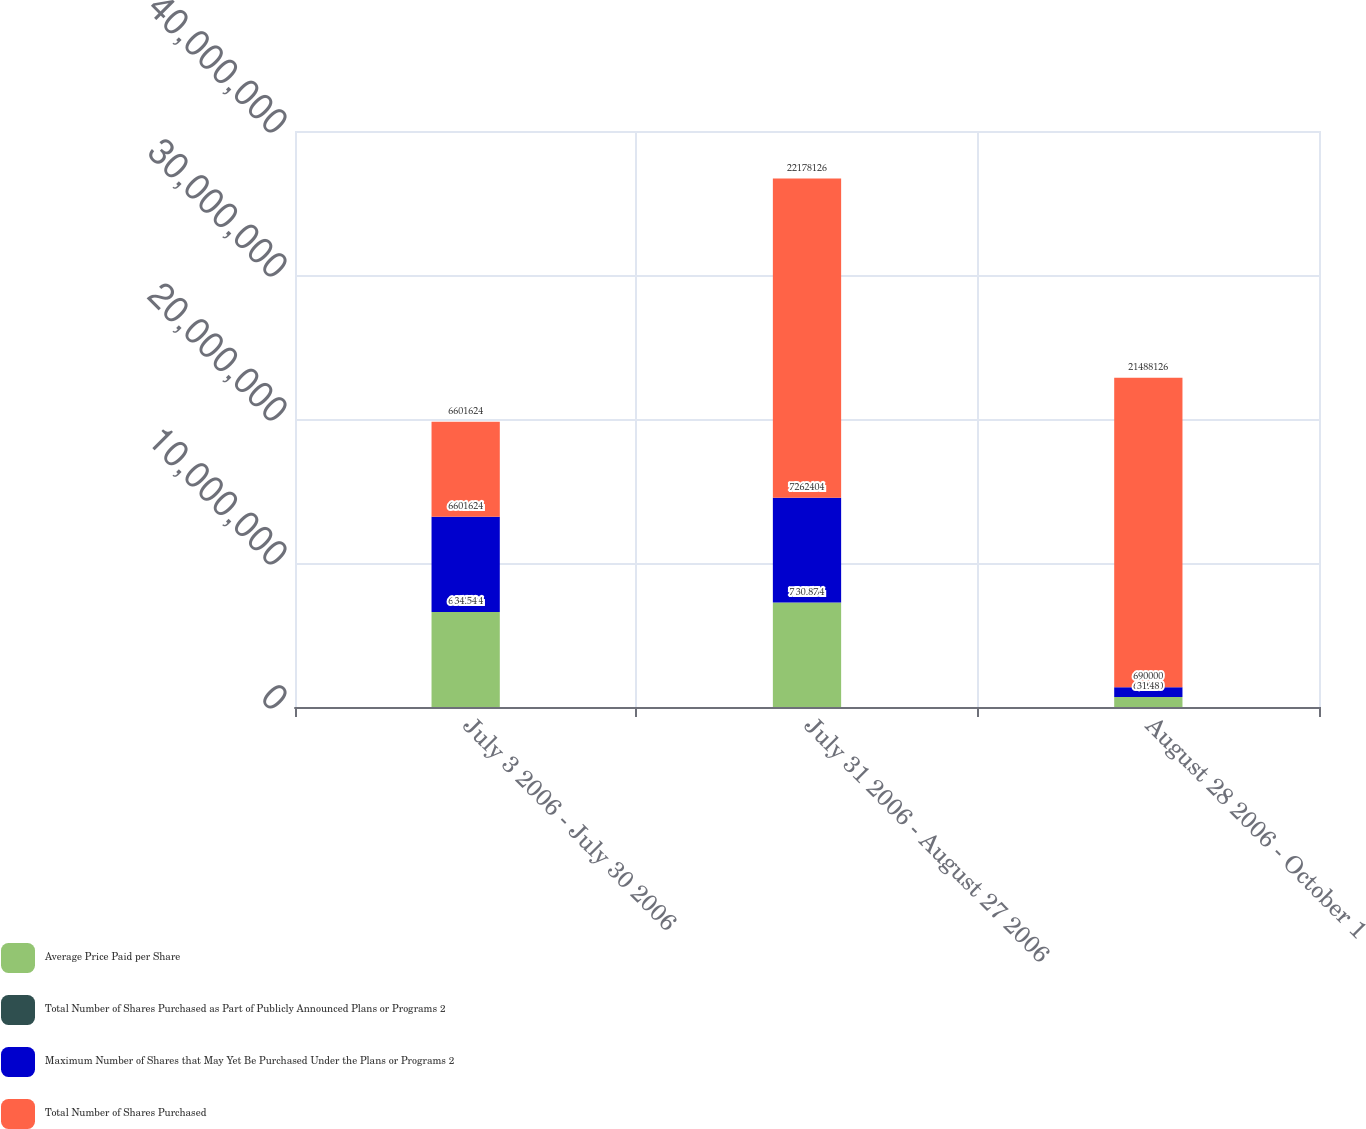Convert chart to OTSL. <chart><loc_0><loc_0><loc_500><loc_500><stacked_bar_chart><ecel><fcel>July 3 2006 - July 30 2006<fcel>July 31 2006 - August 27 2006<fcel>August 28 2006 - October 1<nl><fcel>Average Price Paid per Share<fcel>6.60162e+06<fcel>7.2624e+06<fcel>690000<nl><fcel>Total Number of Shares Purchased as Part of Publicly Announced Plans or Programs 2<fcel>34.54<fcel>30.87<fcel>31.48<nl><fcel>Maximum Number of Shares that May Yet Be Purchased Under the Plans or Programs 2<fcel>6.60162e+06<fcel>7.2624e+06<fcel>690000<nl><fcel>Total Number of Shares Purchased<fcel>6.60162e+06<fcel>2.21781e+07<fcel>2.14881e+07<nl></chart> 